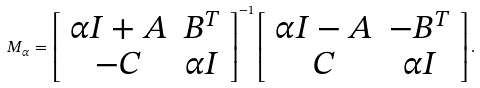Convert formula to latex. <formula><loc_0><loc_0><loc_500><loc_500>M _ { \alpha } = \left [ \begin{array} { c c } \alpha I + A & B ^ { T } \\ - C & \alpha I \\ \end{array} \right ] ^ { - 1 } \left [ \begin{array} { c c } \alpha I - A & - B ^ { T } \\ C & \alpha I \\ \end{array} \right ] .</formula> 